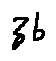Convert formula to latex. <formula><loc_0><loc_0><loc_500><loc_500>z b</formula> 